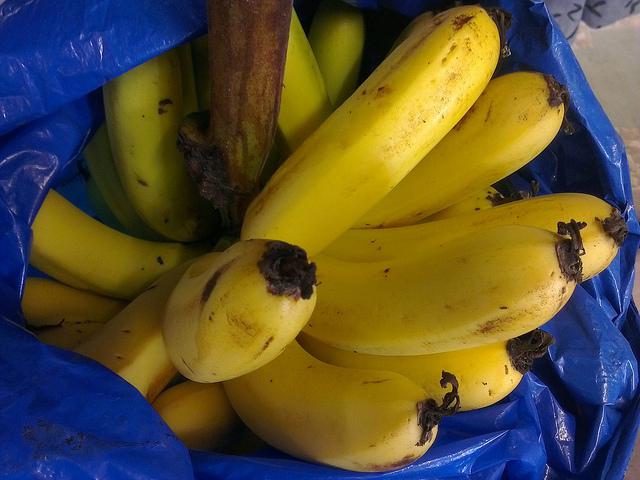Does this fruit grow on a tree?
Keep it brief. Yes. What is the fruit in?
Answer briefly. Bag. What is this fruit called?
Concise answer only. Banana. 